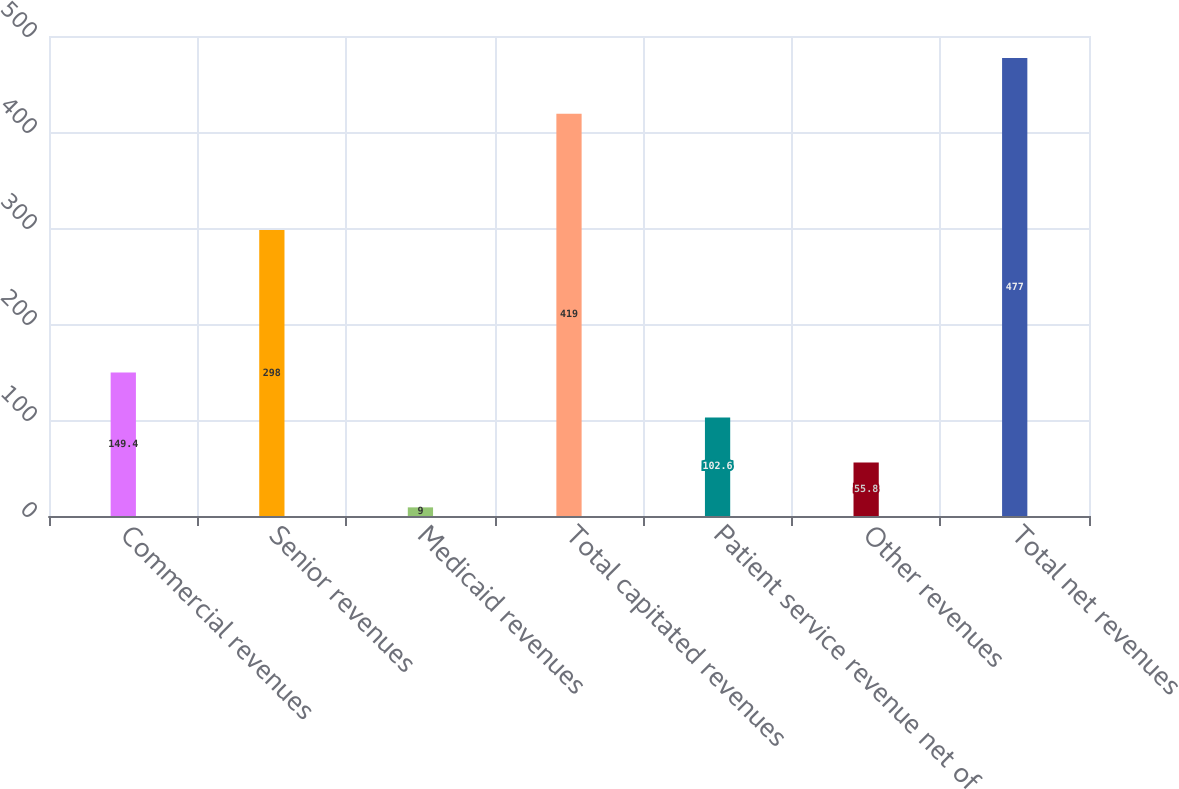Convert chart to OTSL. <chart><loc_0><loc_0><loc_500><loc_500><bar_chart><fcel>Commercial revenues<fcel>Senior revenues<fcel>Medicaid revenues<fcel>Total capitated revenues<fcel>Patient service revenue net of<fcel>Other revenues<fcel>Total net revenues<nl><fcel>149.4<fcel>298<fcel>9<fcel>419<fcel>102.6<fcel>55.8<fcel>477<nl></chart> 